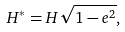Convert formula to latex. <formula><loc_0><loc_0><loc_500><loc_500>H ^ { * } = H \sqrt { 1 - e ^ { 2 } } ,</formula> 